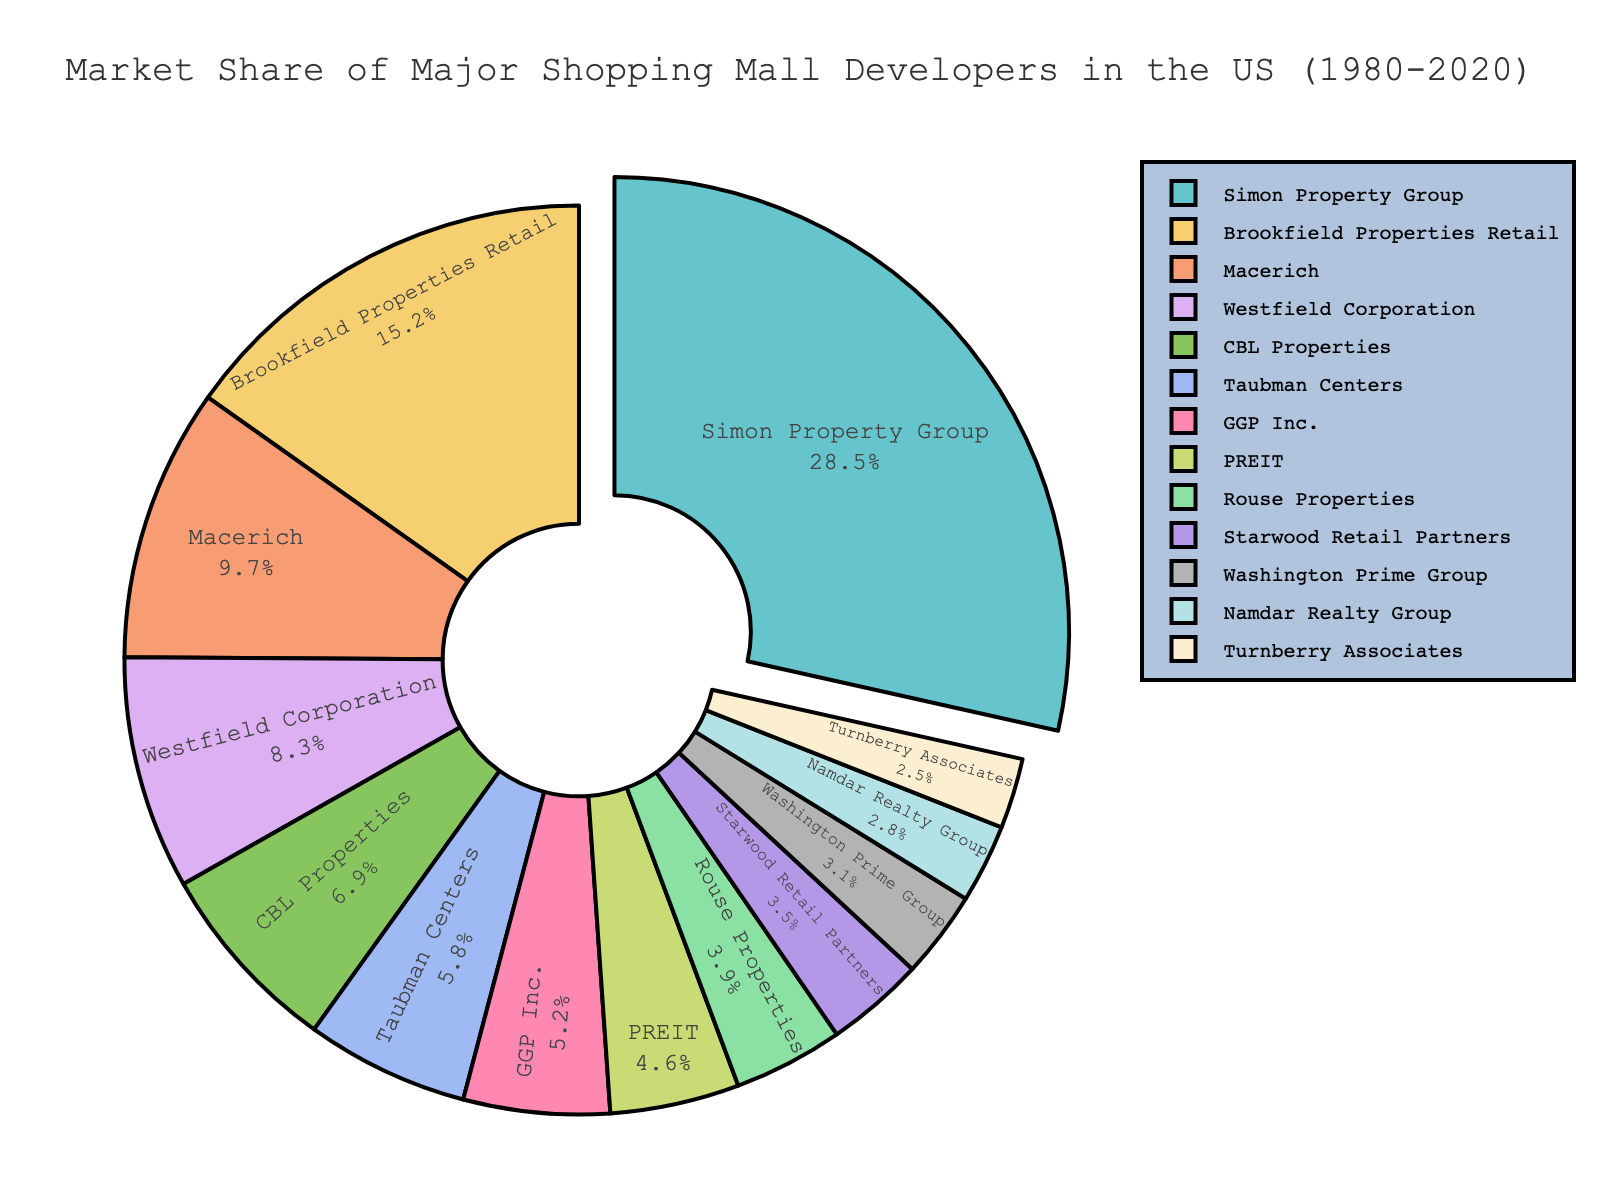Which developer has the highest market share? The developer with the highest market share is shown by the largest slice of the pie chart, which is labeled with their name and market share percentage.
Answer: Simon Property Group Which developers have a market share greater than 10%? To answer this, scan the pie chart for all segments that are labeled with a market share percentage greater than 10%.
Answer: Simon Property Group, Brookfield Properties Retail What is the combined market share of the top three developers? The top three developers are those with the largest slices. Add their market shares: Simon Property Group (28.5%) + Brookfield Properties Retail (15.2%) + Macerich (9.7%) = 53.4%
Answer: 53.4% Which developer has a lower market share: Westfield Corporation or CBL Properties? Compare the market share percentages of Westfield Corporation (8.3%) and CBL Properties (6.9%).
Answer: CBL Properties What is the difference in market share between the largest and smallest developers? Subtract the market share of the smallest developer (Turnberry Associates, 2.5%) from the largest developer (Simon Property Group, 28.5%): 28.5% - 2.5% = 26%
Answer: 26% Which developers have a market share between 5% and 10% inclusive? Look at the slices labeled with percentages falling within the 5%-10% range.
Answer: Macerich, Westfield Corporation, CBL Properties, Taubman Centers, GGP Inc What is the average market share of the developers holding less than 5% each? Identify developers with less than 5% market share and calculate their average. Rouse Properties (3.9%), Starwood Retail Partners (3.5%), Washington Prime Group (3.1%), Namdar Realty Group (2.8%), Turnberry Associates (2.5%). Sum these shares: 3.9% + 3.5% + 3.1% + 2.8% + 2.5% = 15.8%. Divide by the number of developers: 15.8% / 5 = 3.16%
Answer: 3.16% If the combined market share of GGP Inc. and PREIT were to increase by 5%, what would their new combined market share be? First, find their current combined market share: GGP Inc. (5.2%) + PREIT (4.6%) = 9.8%. Add 5% to this total: 9.8% + 5% = 14.8%
Answer: 14.8% Which developer occupies approximately one-fourth of the total market share? One-fourth of the total market share is 25%. Identify the developer with a market share closest to 25%, which is Simon Property Group with 28.5%.
Answer: Simon Property Group 